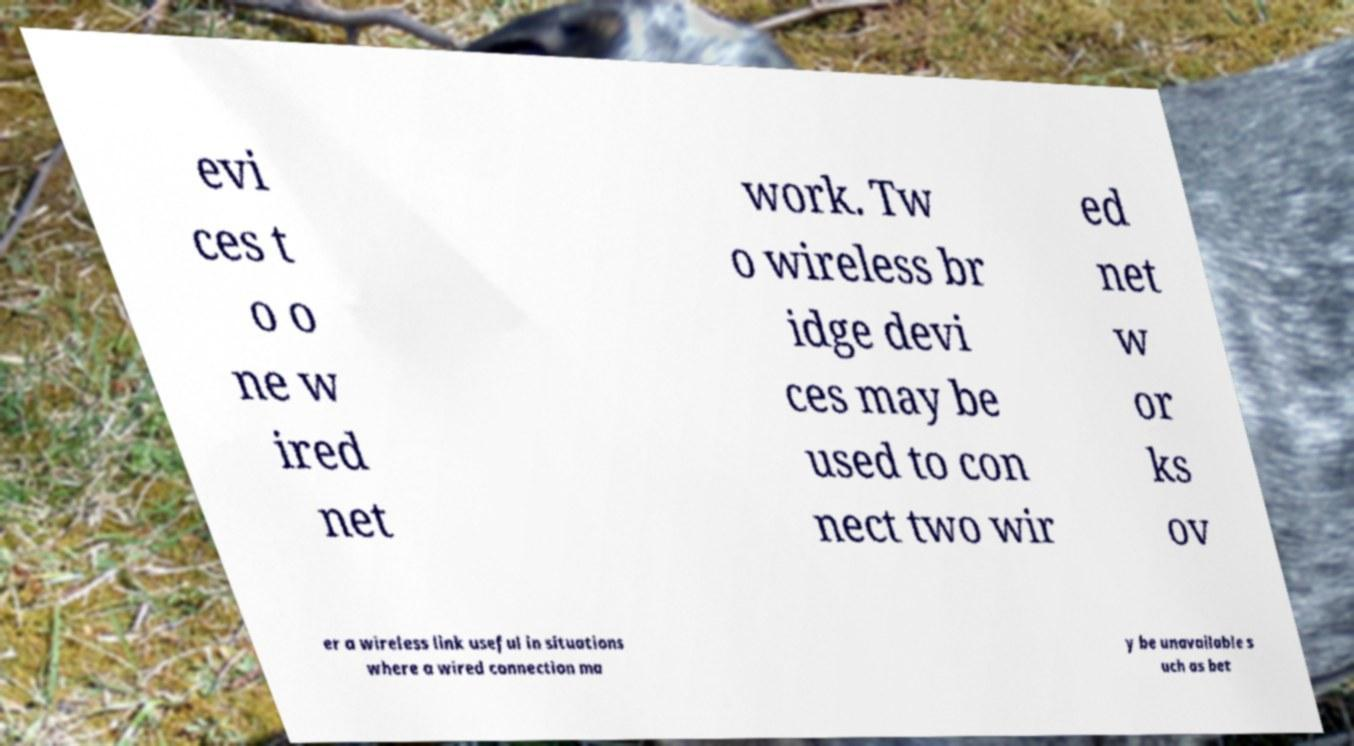Can you read and provide the text displayed in the image?This photo seems to have some interesting text. Can you extract and type it out for me? evi ces t o o ne w ired net work. Tw o wireless br idge devi ces may be used to con nect two wir ed net w or ks ov er a wireless link useful in situations where a wired connection ma y be unavailable s uch as bet 